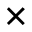Convert formula to latex. <formula><loc_0><loc_0><loc_500><loc_500>\times</formula> 